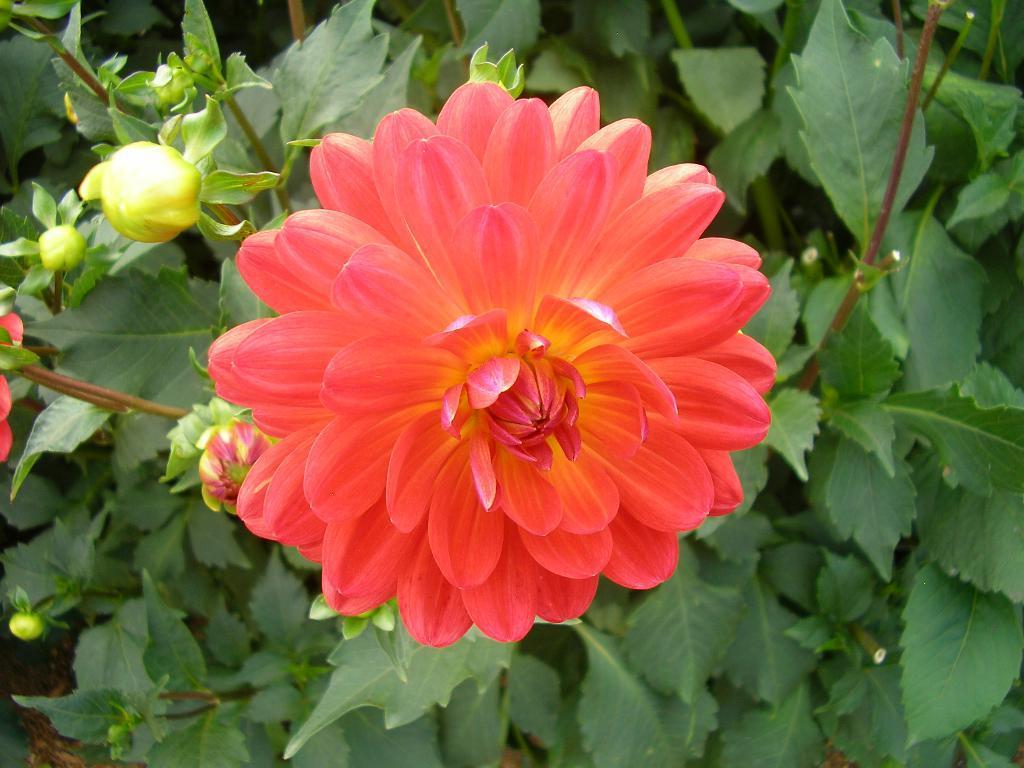Describe this image in one or two sentences. This is the flower with petals, which is dark peach in color. I can see flower buds. These are the leaves. I think this is the plant. 